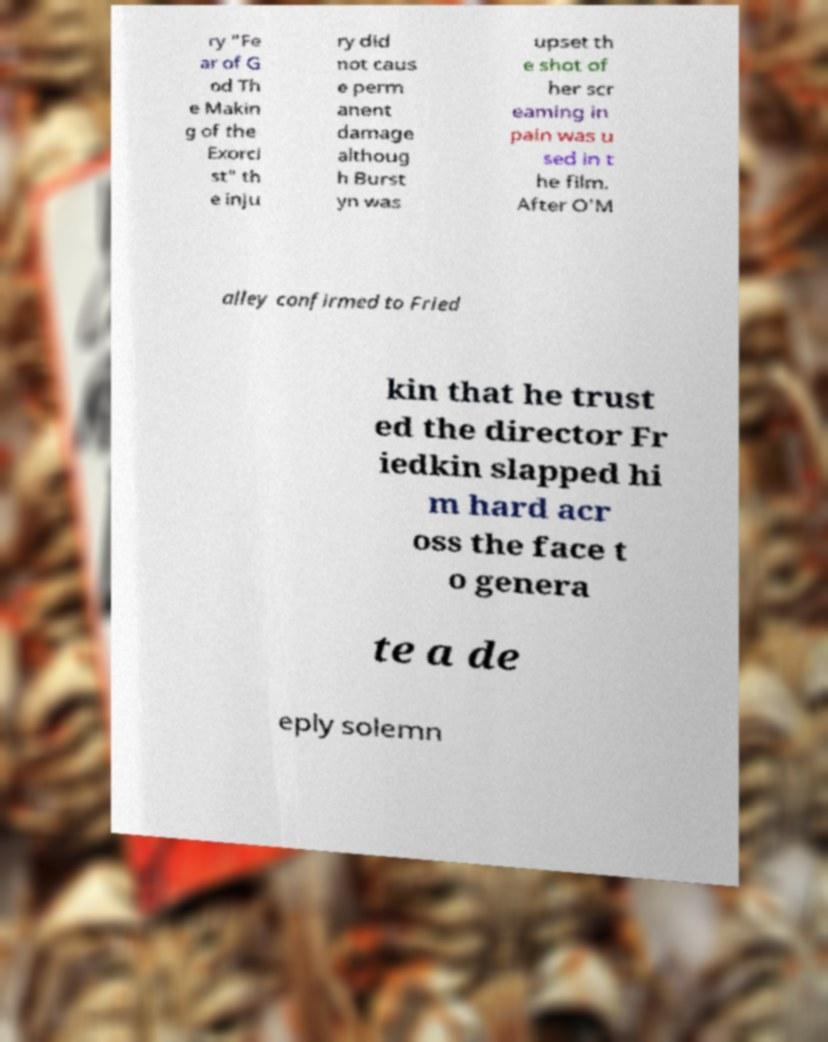Could you extract and type out the text from this image? ry "Fe ar of G od Th e Makin g of the Exorci st" th e inju ry did not caus e perm anent damage althoug h Burst yn was upset th e shot of her scr eaming in pain was u sed in t he film. After O'M alley confirmed to Fried kin that he trust ed the director Fr iedkin slapped hi m hard acr oss the face t o genera te a de eply solemn 